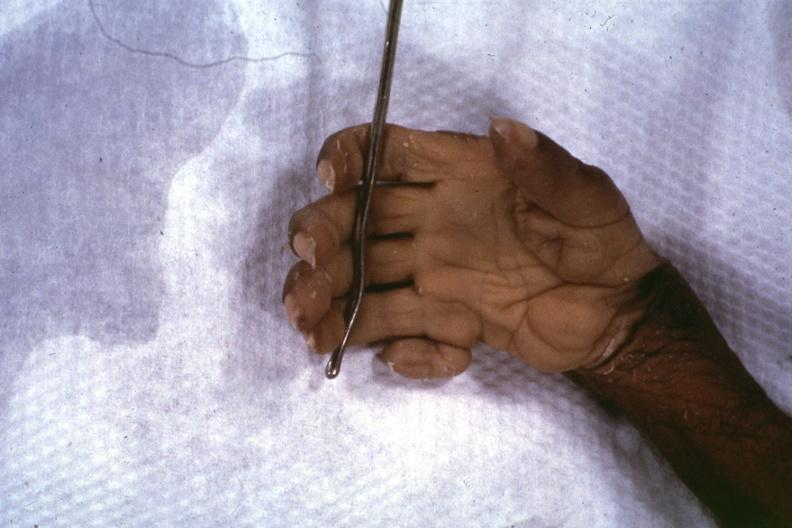what is present?
Answer the question using a single word or phrase. Hand 